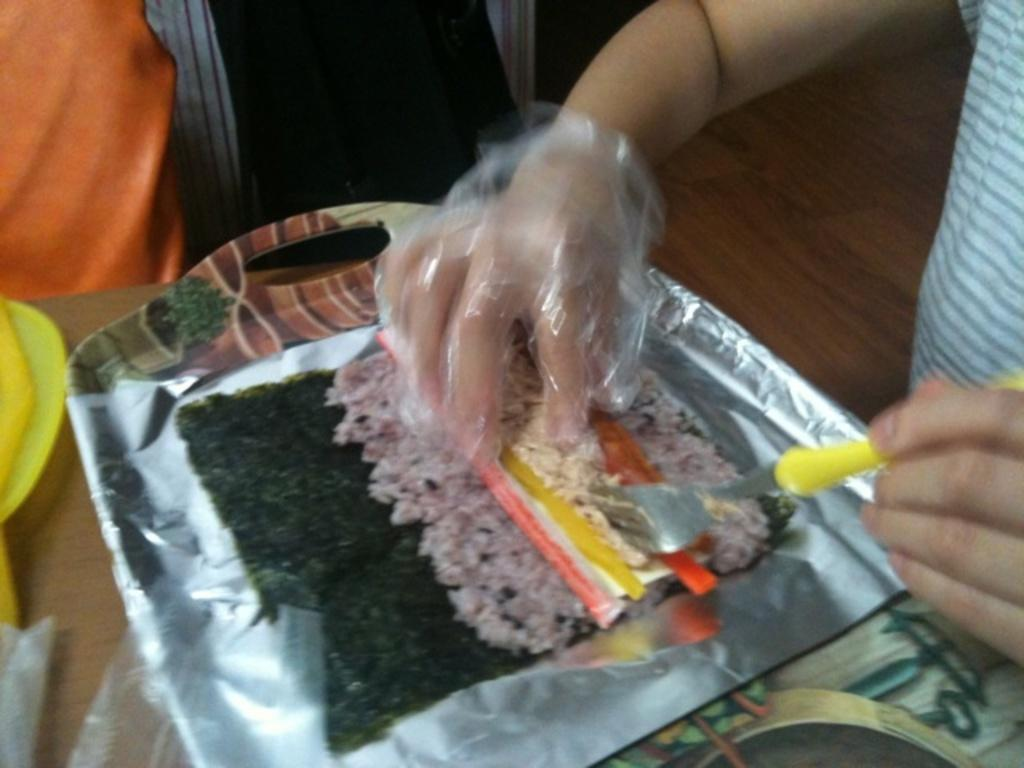What is the main subject of the image? There is a person in the image. What is the person holding in one hand? The person is holding an edible in one hand. What is the person holding in the other hand? The person is holding a fork in the other hand. What else can be seen in the image besides the person? There are other objects beside the person. What color is the paint on the tent in the image? There is no paint or tent present in the image. What rule is being enforced by the person in the image? There is no indication of a rule or enforcement in the image. 